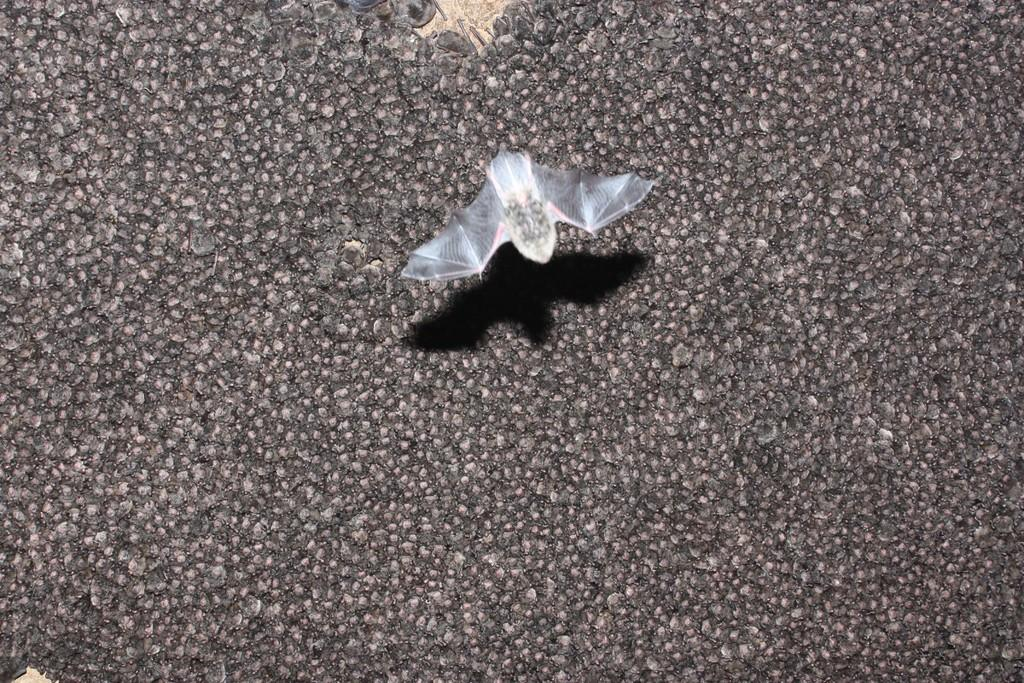What is the main subject in the center of the image? There is a bat in the center of the image. Can you describe the background of the image? There are bats in the background of the image. What type of cake is being served at the party in the image? There is no cake or party present in the image; it features a bat in the center and bats in the background. How many spots can be seen on the ladybug in the image? There is no ladybug present in the image; it features a bat in the center and bats in the background. 